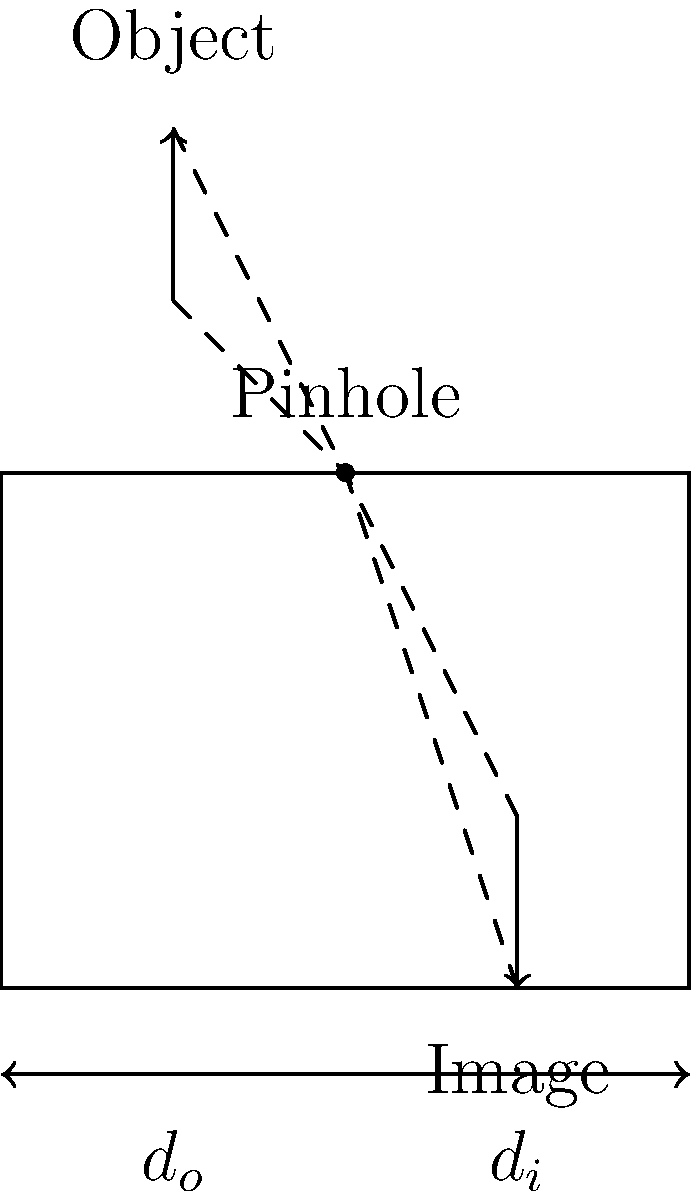In a pinhole camera, an object of height $h_o$ is placed at a distance $d_o$ from the pinhole, and its image is formed at a distance $d_i$ behind the pinhole. Using the ray diagram, derive the equation for the height of the image $h_i$ in terms of $h_o$, $d_o$, and $d_i$. To derive the equation for the image height, let's follow these steps:

1. Observe that the light rays form similar triangles on both sides of the pinhole.

2. The ratio of the heights of these triangles will be equal to the ratio of their bases. We can express this as:

   $$\frac{h_o}{d_o} = \frac{h_i}{d_i}$$

3. Cross-multiply to get:

   $$h_o \cdot d_i = h_i \cdot d_o$$

4. Solve for $h_i$:

   $$h_i = \frac{h_o \cdot d_i}{d_o}$$

5. This equation shows that the image height is directly proportional to the object height and the image distance, and inversely proportional to the object distance.

6. Note that the negative sign is not included in this equation. The inverted nature of the image is represented by the direction of the arrow in the diagram.

This equation demonstrates how a pinhole camera forms an inverted image of an object, which is a fundamental principle in photography that you, as a young photographer, would find particularly relevant to understanding the physics behind image formation.
Answer: $h_i = \frac{h_o \cdot d_i}{d_o}$ 